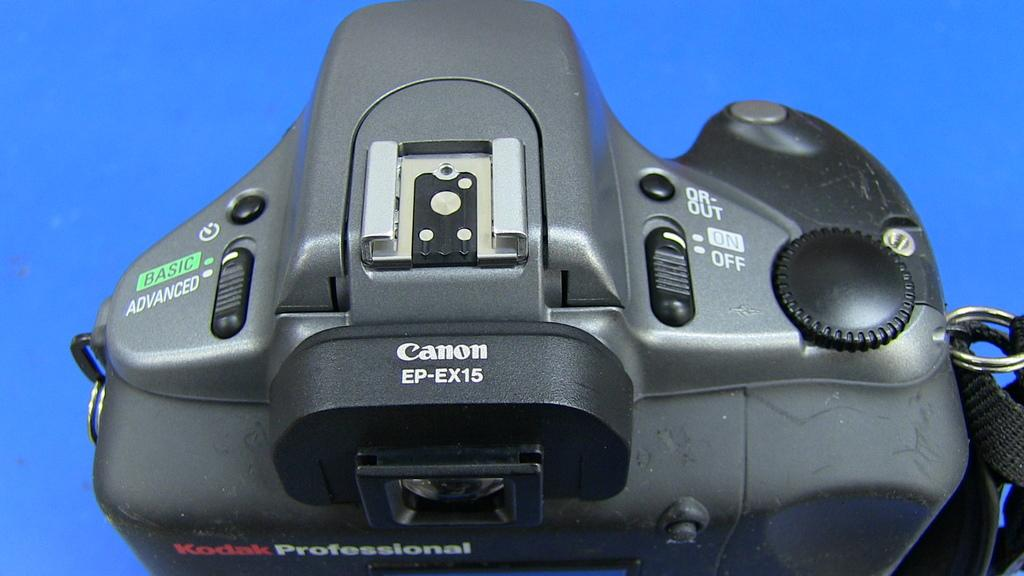<image>
Write a terse but informative summary of the picture. a camera that has the word canon on the top 